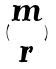Convert formula to latex. <formula><loc_0><loc_0><loc_500><loc_500>( \begin{matrix} m \\ r \end{matrix} )</formula> 